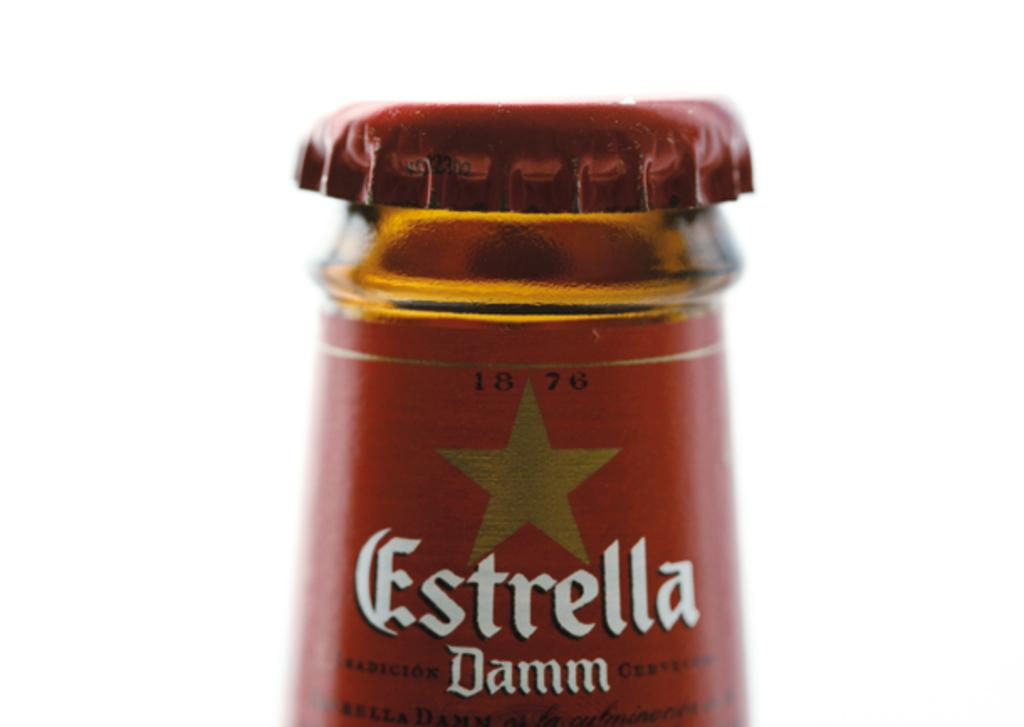<image>
Summarize the visual content of the image. The top portions and the bottle cap of Estrella beer is shown. 